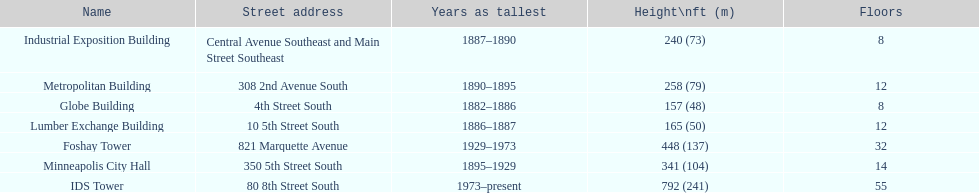Name the tallest building. IDS Tower. 